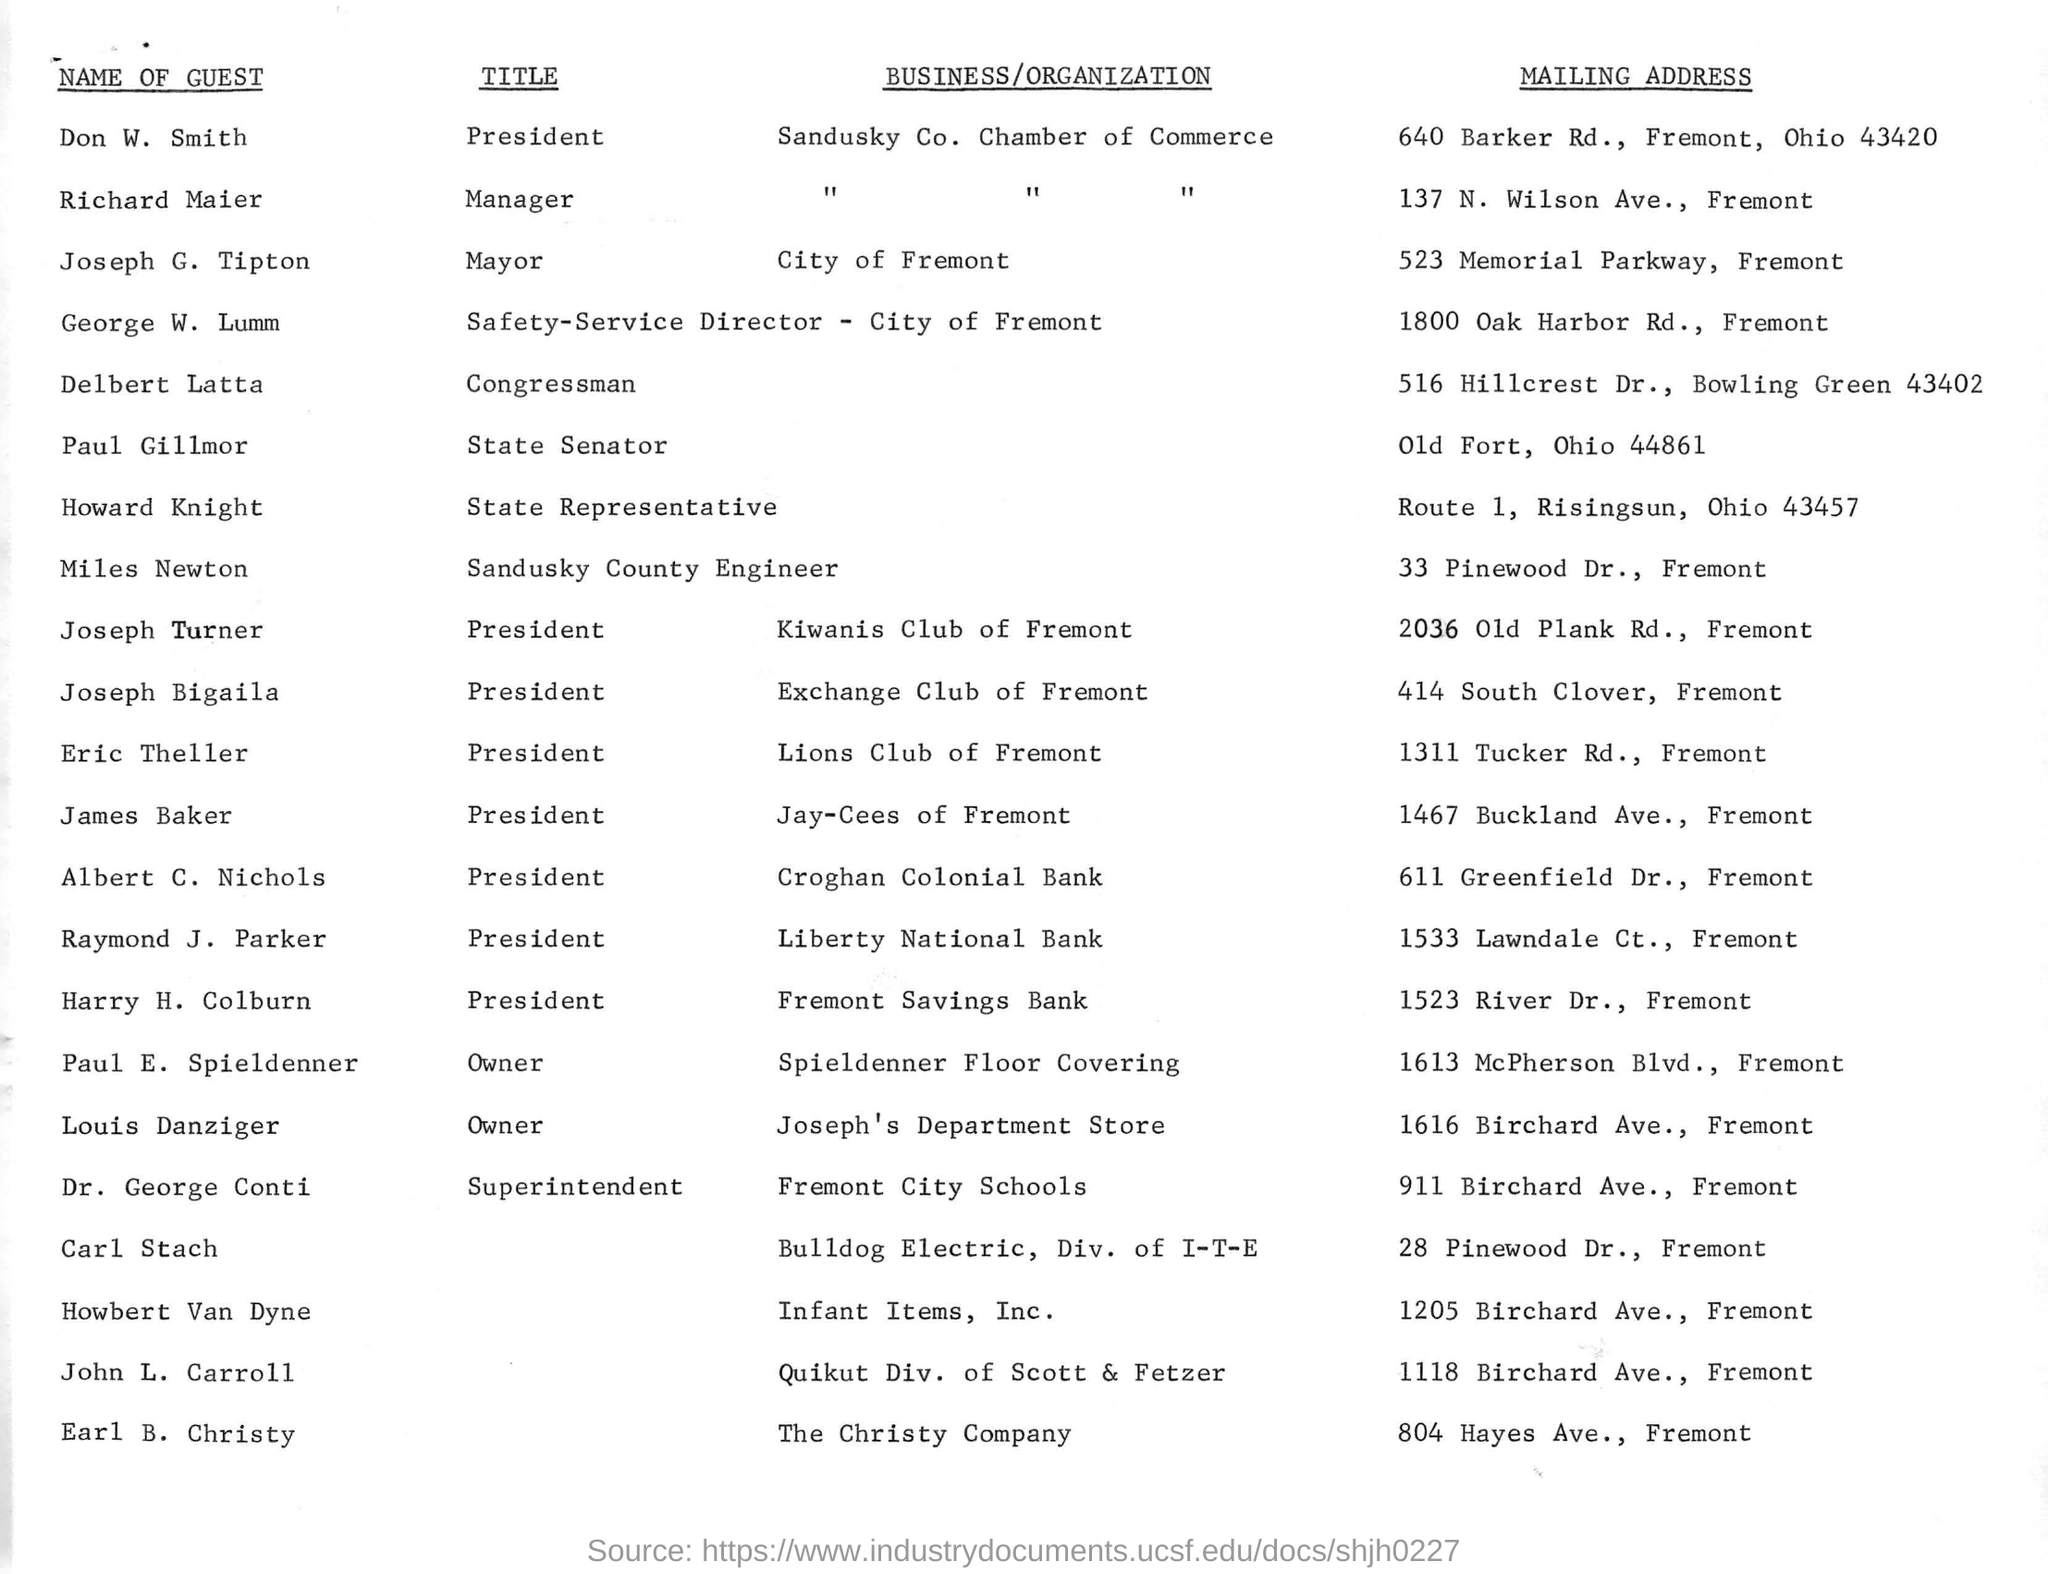Who is the Mayor of City of Fremont?
Give a very brief answer. Joseph G. Tipton. Where is The Christy Company located?
Provide a succinct answer. 804 Hayes Ave., Fremont. What is the title of Raymond J. Parker?
Make the answer very short. President. Which organization is owned by Louis Danziger?
Offer a very short reply. Joseph's Department Store. 